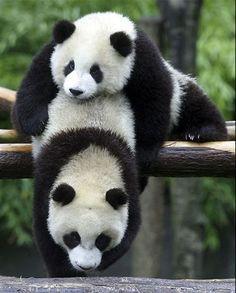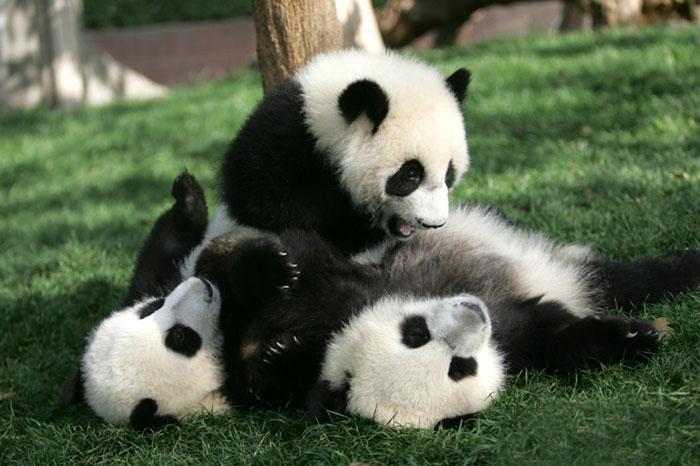The first image is the image on the left, the second image is the image on the right. Assess this claim about the two images: "There are exactly three pandas in the right image.". Correct or not? Answer yes or no. Yes. The first image is the image on the left, the second image is the image on the right. Evaluate the accuracy of this statement regarding the images: "There are four panda bears next to each other.". Is it true? Answer yes or no. No. 